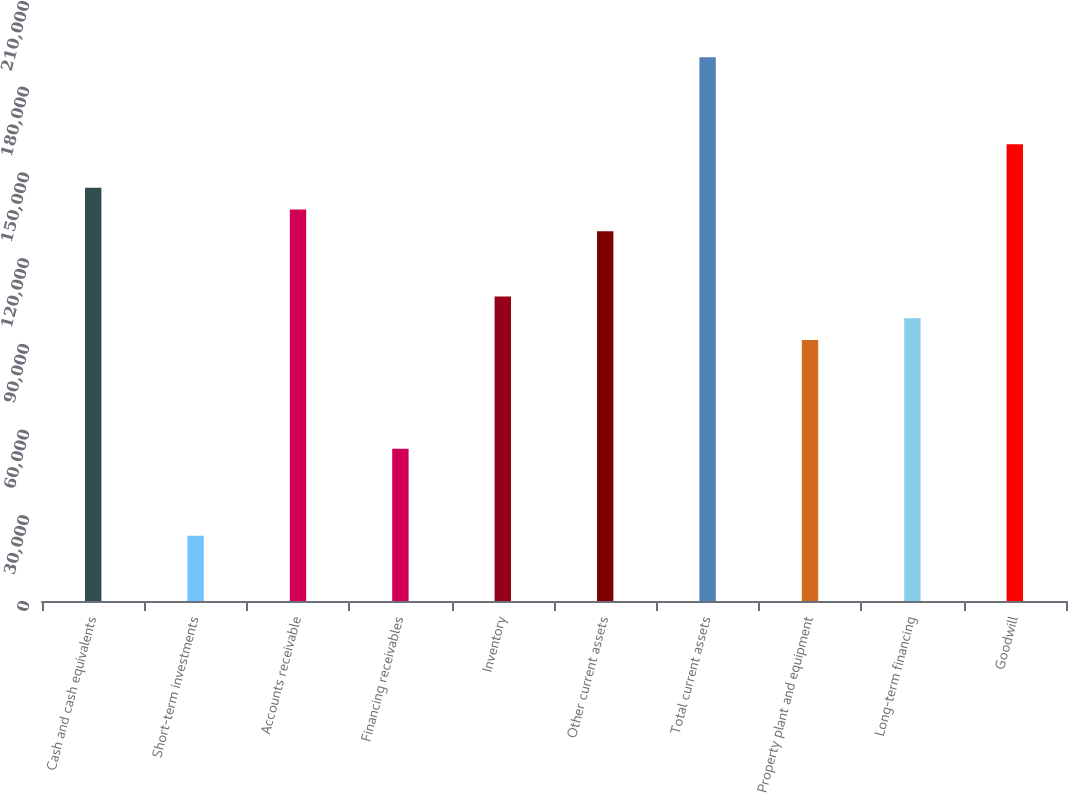Convert chart. <chart><loc_0><loc_0><loc_500><loc_500><bar_chart><fcel>Cash and cash equivalents<fcel>Short-term investments<fcel>Accounts receivable<fcel>Financing receivables<fcel>Inventory<fcel>Other current assets<fcel>Total current assets<fcel>Property plant and equipment<fcel>Long-term financing<fcel>Goodwill<nl><fcel>144636<fcel>22861.7<fcel>137025<fcel>53305.3<fcel>106582<fcel>129414<fcel>190302<fcel>91359.8<fcel>98970.7<fcel>159858<nl></chart> 